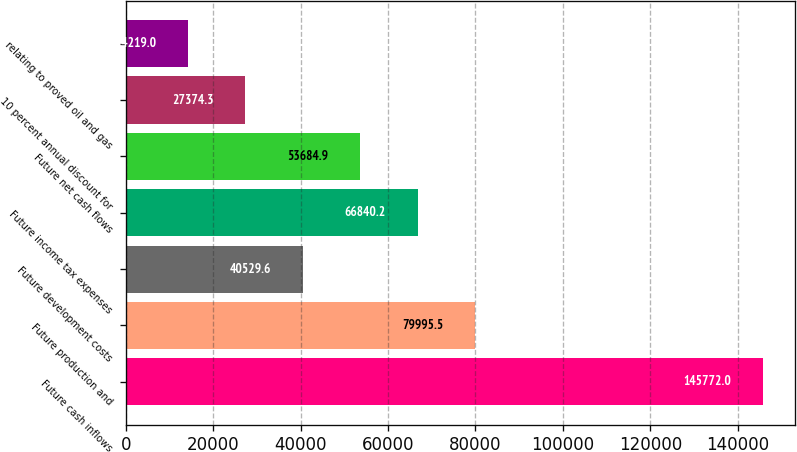Convert chart to OTSL. <chart><loc_0><loc_0><loc_500><loc_500><bar_chart><fcel>Future cash inflows<fcel>Future production and<fcel>Future development costs<fcel>Future income tax expenses<fcel>Future net cash flows<fcel>10 percent annual discount for<fcel>relating to proved oil and gas<nl><fcel>145772<fcel>79995.5<fcel>40529.6<fcel>66840.2<fcel>53684.9<fcel>27374.3<fcel>14219<nl></chart> 